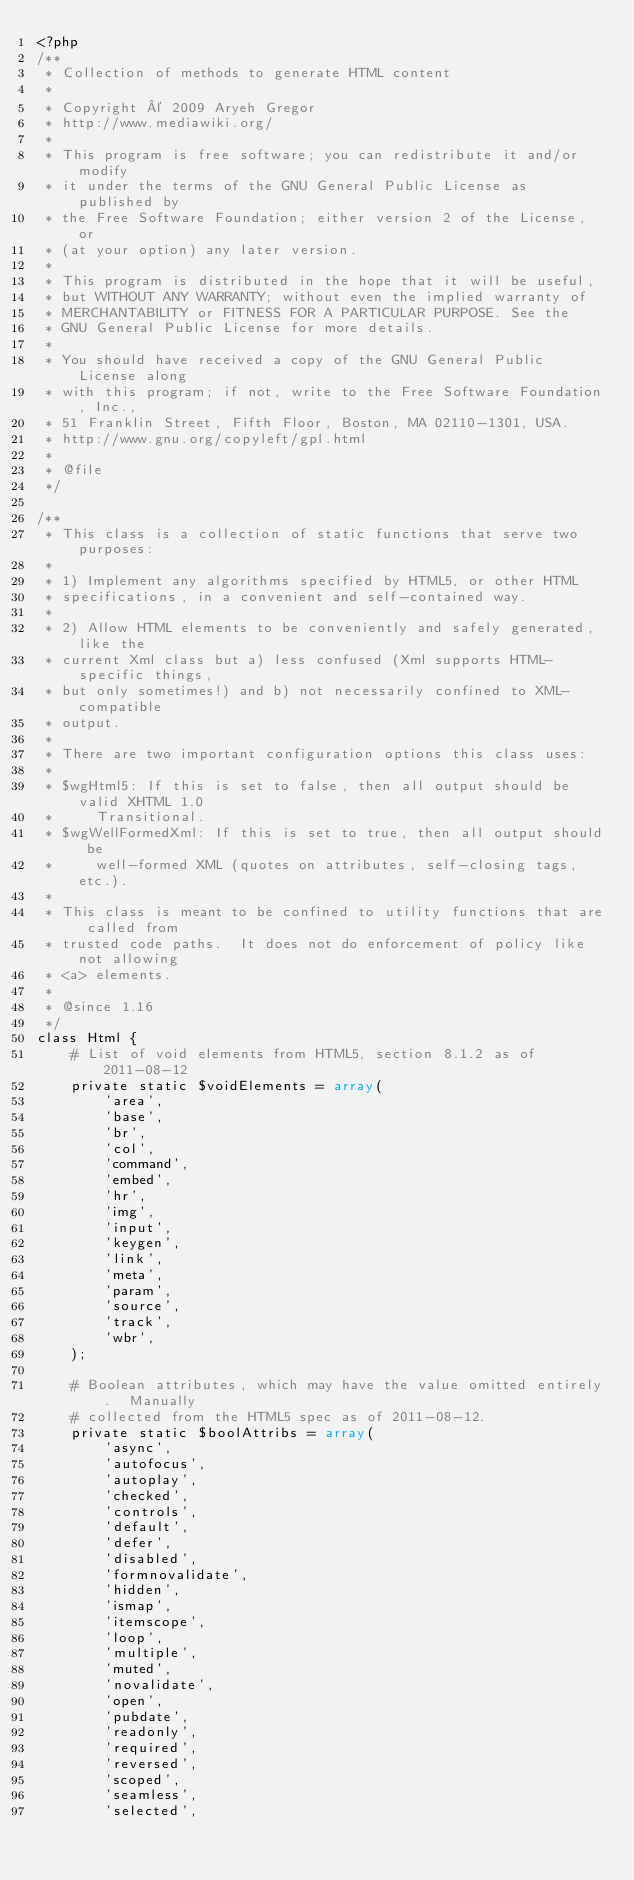<code> <loc_0><loc_0><loc_500><loc_500><_PHP_><?php
/**
 * Collection of methods to generate HTML content
 *
 * Copyright © 2009 Aryeh Gregor
 * http://www.mediawiki.org/
 *
 * This program is free software; you can redistribute it and/or modify
 * it under the terms of the GNU General Public License as published by
 * the Free Software Foundation; either version 2 of the License, or
 * (at your option) any later version.
 *
 * This program is distributed in the hope that it will be useful,
 * but WITHOUT ANY WARRANTY; without even the implied warranty of
 * MERCHANTABILITY or FITNESS FOR A PARTICULAR PURPOSE. See the
 * GNU General Public License for more details.
 *
 * You should have received a copy of the GNU General Public License along
 * with this program; if not, write to the Free Software Foundation, Inc.,
 * 51 Franklin Street, Fifth Floor, Boston, MA 02110-1301, USA.
 * http://www.gnu.org/copyleft/gpl.html
 *
 * @file
 */

/**
 * This class is a collection of static functions that serve two purposes:
 *
 * 1) Implement any algorithms specified by HTML5, or other HTML
 * specifications, in a convenient and self-contained way.
 *
 * 2) Allow HTML elements to be conveniently and safely generated, like the
 * current Xml class but a) less confused (Xml supports HTML-specific things,
 * but only sometimes!) and b) not necessarily confined to XML-compatible
 * output.
 *
 * There are two important configuration options this class uses:
 *
 * $wgHtml5: If this is set to false, then all output should be valid XHTML 1.0
 *     Transitional.
 * $wgWellFormedXml: If this is set to true, then all output should be
 *     well-formed XML (quotes on attributes, self-closing tags, etc.).
 *
 * This class is meant to be confined to utility functions that are called from
 * trusted code paths.  It does not do enforcement of policy like not allowing
 * <a> elements.
 *
 * @since 1.16
 */
class Html {
	# List of void elements from HTML5, section 8.1.2 as of 2011-08-12
	private static $voidElements = array(
		'area',
		'base',
		'br',
		'col',
		'command',
		'embed',
		'hr',
		'img',
		'input',
		'keygen',
		'link',
		'meta',
		'param',
		'source',
		'track',
		'wbr',
	);

	# Boolean attributes, which may have the value omitted entirely.  Manually
	# collected from the HTML5 spec as of 2011-08-12.
	private static $boolAttribs = array(
		'async',
		'autofocus',
		'autoplay',
		'checked',
		'controls',
		'default',
		'defer',
		'disabled',
		'formnovalidate',
		'hidden',
		'ismap',
		'itemscope',
		'loop',
		'multiple',
		'muted',
		'novalidate',
		'open',
		'pubdate',
		'readonly',
		'required',
		'reversed',
		'scoped',
		'seamless',
		'selected',</code> 